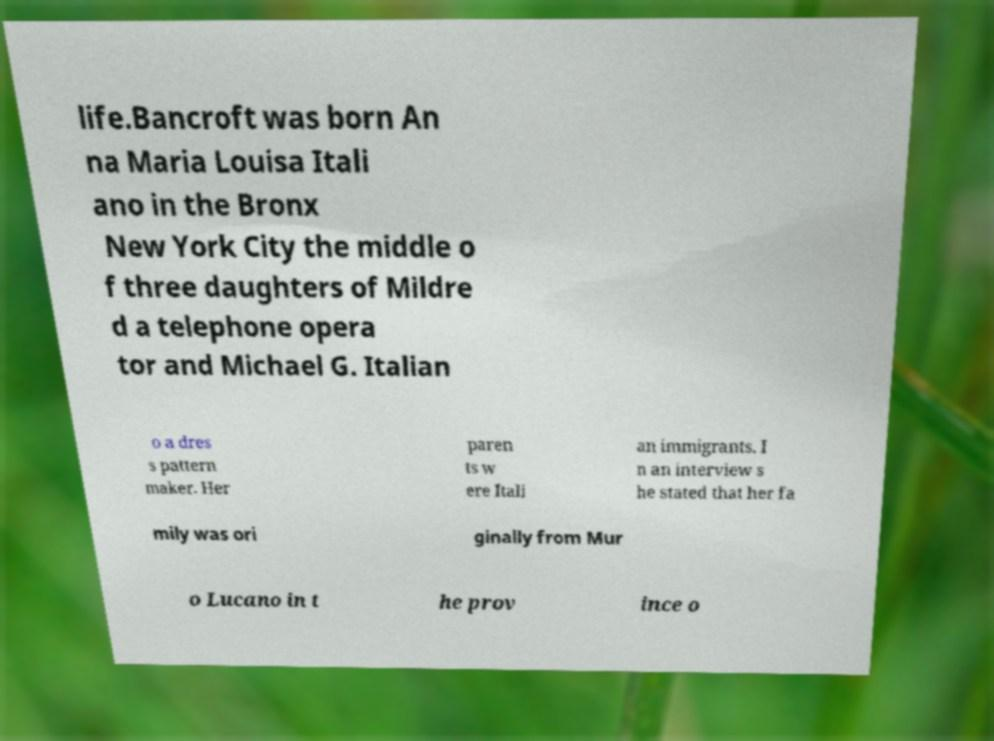Can you read and provide the text displayed in the image?This photo seems to have some interesting text. Can you extract and type it out for me? life.Bancroft was born An na Maria Louisa Itali ano in the Bronx New York City the middle o f three daughters of Mildre d a telephone opera tor and Michael G. Italian o a dres s pattern maker. Her paren ts w ere Itali an immigrants. I n an interview s he stated that her fa mily was ori ginally from Mur o Lucano in t he prov ince o 